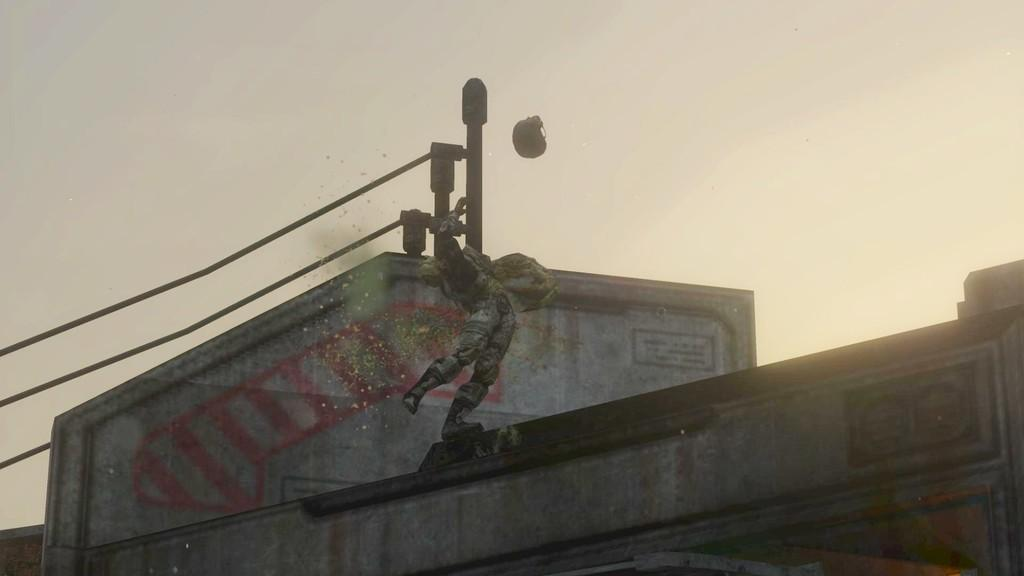What is the main subject of the image? The main subject of the image is the top of a building. What object can be seen near the building? There is a pole in the image. How is the pole connected to other structures? Cables are connected to the pole. What can be seen in the background of the image? The sky is visible in the image. What type of print can be seen on the building's facade in the image? There is no print visible on the building's facade in the image. How does the spoon interact with the pole in the image? There is no spoon present in the image, so it cannot interact with the pole. 